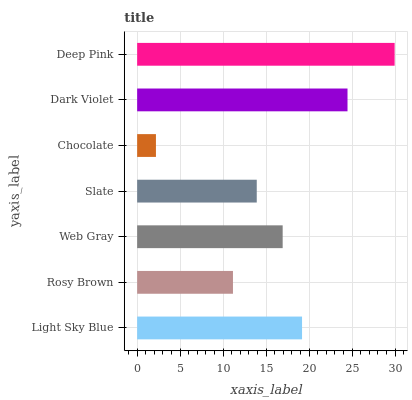Is Chocolate the minimum?
Answer yes or no. Yes. Is Deep Pink the maximum?
Answer yes or no. Yes. Is Rosy Brown the minimum?
Answer yes or no. No. Is Rosy Brown the maximum?
Answer yes or no. No. Is Light Sky Blue greater than Rosy Brown?
Answer yes or no. Yes. Is Rosy Brown less than Light Sky Blue?
Answer yes or no. Yes. Is Rosy Brown greater than Light Sky Blue?
Answer yes or no. No. Is Light Sky Blue less than Rosy Brown?
Answer yes or no. No. Is Web Gray the high median?
Answer yes or no. Yes. Is Web Gray the low median?
Answer yes or no. Yes. Is Light Sky Blue the high median?
Answer yes or no. No. Is Dark Violet the low median?
Answer yes or no. No. 